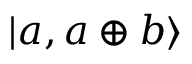Convert formula to latex. <formula><loc_0><loc_0><loc_500><loc_500>| a , a \oplus b \rangle</formula> 